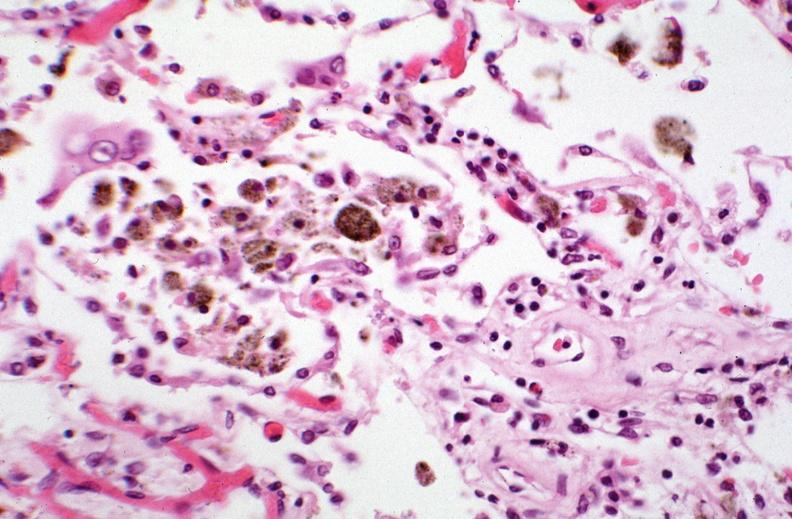what is present?
Answer the question using a single word or phrase. Respiratory 